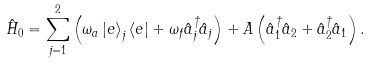Convert formula to latex. <formula><loc_0><loc_0><loc_500><loc_500>\hat { H } _ { 0 } = \sum ^ { 2 } _ { j = 1 } \left ( \omega _ { a } \left | e \right > _ { j } \left < e \right | + \omega _ { f } \hat { a } ^ { \dagger } _ { j } \hat { a } _ { j } \right ) + A \left ( \hat { a } ^ { \dagger } _ { 1 } \hat { a } _ { 2 } + \hat { a } ^ { \dagger } _ { 2 } \hat { a } _ { 1 } \right ) .</formula> 